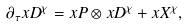<formula> <loc_0><loc_0><loc_500><loc_500>\partial _ { \tau } x D ^ { \chi } = x P \otimes x D ^ { \chi } + x X ^ { \chi } ,</formula> 